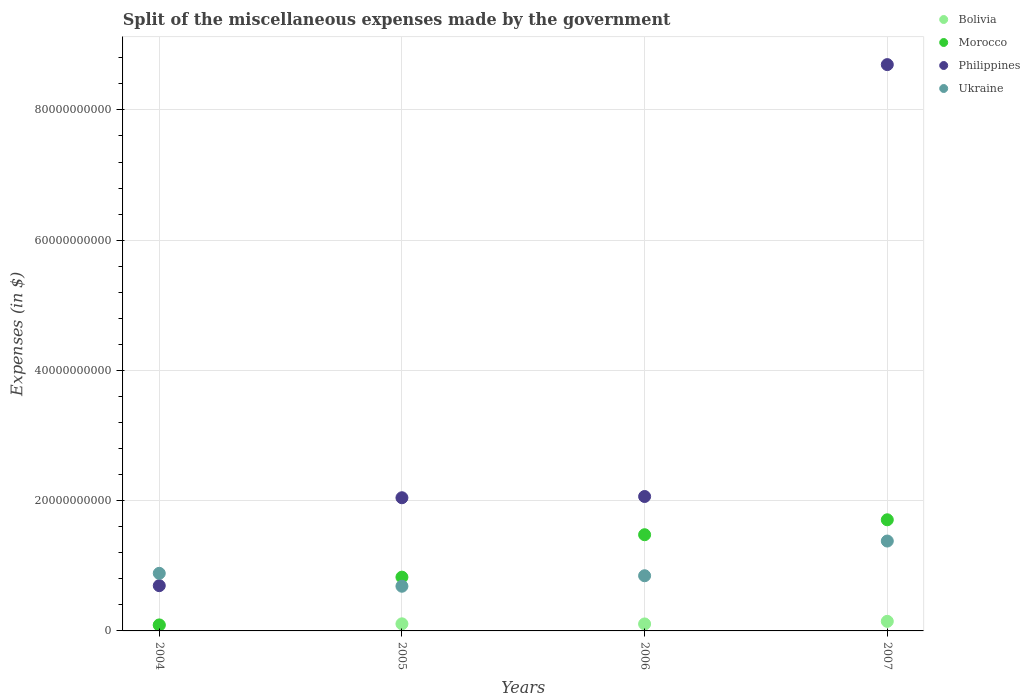How many different coloured dotlines are there?
Provide a short and direct response. 4. What is the miscellaneous expenses made by the government in Morocco in 2006?
Ensure brevity in your answer.  1.48e+1. Across all years, what is the maximum miscellaneous expenses made by the government in Ukraine?
Make the answer very short. 1.38e+1. Across all years, what is the minimum miscellaneous expenses made by the government in Morocco?
Keep it short and to the point. 9.22e+08. What is the total miscellaneous expenses made by the government in Bolivia in the graph?
Provide a succinct answer. 4.49e+09. What is the difference between the miscellaneous expenses made by the government in Ukraine in 2005 and that in 2007?
Ensure brevity in your answer.  -6.94e+09. What is the difference between the miscellaneous expenses made by the government in Philippines in 2005 and the miscellaneous expenses made by the government in Morocco in 2007?
Offer a very short reply. 3.39e+09. What is the average miscellaneous expenses made by the government in Bolivia per year?
Your answer should be compact. 1.12e+09. In the year 2007, what is the difference between the miscellaneous expenses made by the government in Morocco and miscellaneous expenses made by the government in Philippines?
Ensure brevity in your answer.  -6.99e+1. In how many years, is the miscellaneous expenses made by the government in Philippines greater than 32000000000 $?
Make the answer very short. 1. What is the ratio of the miscellaneous expenses made by the government in Philippines in 2006 to that in 2007?
Give a very brief answer. 0.24. Is the miscellaneous expenses made by the government in Ukraine in 2004 less than that in 2006?
Offer a terse response. No. Is the difference between the miscellaneous expenses made by the government in Morocco in 2006 and 2007 greater than the difference between the miscellaneous expenses made by the government in Philippines in 2006 and 2007?
Provide a succinct answer. Yes. What is the difference between the highest and the second highest miscellaneous expenses made by the government in Philippines?
Your answer should be very brief. 6.63e+1. What is the difference between the highest and the lowest miscellaneous expenses made by the government in Ukraine?
Your answer should be compact. 6.94e+09. Is it the case that in every year, the sum of the miscellaneous expenses made by the government in Bolivia and miscellaneous expenses made by the government in Philippines  is greater than the miscellaneous expenses made by the government in Ukraine?
Ensure brevity in your answer.  No. Does the miscellaneous expenses made by the government in Bolivia monotonically increase over the years?
Offer a very short reply. No. Is the miscellaneous expenses made by the government in Ukraine strictly greater than the miscellaneous expenses made by the government in Bolivia over the years?
Your answer should be very brief. Yes. How many years are there in the graph?
Offer a very short reply. 4. What is the difference between two consecutive major ticks on the Y-axis?
Offer a very short reply. 2.00e+1. Are the values on the major ticks of Y-axis written in scientific E-notation?
Offer a very short reply. No. Where does the legend appear in the graph?
Offer a terse response. Top right. How many legend labels are there?
Make the answer very short. 4. What is the title of the graph?
Your answer should be very brief. Split of the miscellaneous expenses made by the government. What is the label or title of the X-axis?
Your answer should be compact. Years. What is the label or title of the Y-axis?
Provide a succinct answer. Expenses (in $). What is the Expenses (in $) in Bolivia in 2004?
Offer a terse response. 8.59e+08. What is the Expenses (in $) in Morocco in 2004?
Provide a short and direct response. 9.22e+08. What is the Expenses (in $) of Philippines in 2004?
Offer a terse response. 6.95e+09. What is the Expenses (in $) of Ukraine in 2004?
Your answer should be compact. 8.84e+09. What is the Expenses (in $) in Bolivia in 2005?
Make the answer very short. 1.09e+09. What is the Expenses (in $) in Morocco in 2005?
Provide a succinct answer. 8.26e+09. What is the Expenses (in $) of Philippines in 2005?
Your answer should be very brief. 2.04e+1. What is the Expenses (in $) of Ukraine in 2005?
Your answer should be compact. 6.86e+09. What is the Expenses (in $) in Bolivia in 2006?
Provide a short and direct response. 1.07e+09. What is the Expenses (in $) in Morocco in 2006?
Offer a very short reply. 1.48e+1. What is the Expenses (in $) of Philippines in 2006?
Keep it short and to the point. 2.06e+1. What is the Expenses (in $) of Ukraine in 2006?
Offer a very short reply. 8.47e+09. What is the Expenses (in $) of Bolivia in 2007?
Provide a short and direct response. 1.47e+09. What is the Expenses (in $) of Morocco in 2007?
Your answer should be compact. 1.71e+1. What is the Expenses (in $) in Philippines in 2007?
Provide a short and direct response. 8.70e+1. What is the Expenses (in $) of Ukraine in 2007?
Your answer should be very brief. 1.38e+1. Across all years, what is the maximum Expenses (in $) of Bolivia?
Offer a terse response. 1.47e+09. Across all years, what is the maximum Expenses (in $) of Morocco?
Give a very brief answer. 1.71e+1. Across all years, what is the maximum Expenses (in $) in Philippines?
Ensure brevity in your answer.  8.70e+1. Across all years, what is the maximum Expenses (in $) in Ukraine?
Your response must be concise. 1.38e+1. Across all years, what is the minimum Expenses (in $) of Bolivia?
Offer a terse response. 8.59e+08. Across all years, what is the minimum Expenses (in $) of Morocco?
Your answer should be very brief. 9.22e+08. Across all years, what is the minimum Expenses (in $) in Philippines?
Offer a terse response. 6.95e+09. Across all years, what is the minimum Expenses (in $) of Ukraine?
Give a very brief answer. 6.86e+09. What is the total Expenses (in $) of Bolivia in the graph?
Give a very brief answer. 4.49e+09. What is the total Expenses (in $) in Morocco in the graph?
Give a very brief answer. 4.10e+1. What is the total Expenses (in $) in Philippines in the graph?
Offer a terse response. 1.35e+11. What is the total Expenses (in $) in Ukraine in the graph?
Provide a short and direct response. 3.80e+1. What is the difference between the Expenses (in $) in Bolivia in 2004 and that in 2005?
Your answer should be very brief. -2.29e+08. What is the difference between the Expenses (in $) of Morocco in 2004 and that in 2005?
Make the answer very short. -7.33e+09. What is the difference between the Expenses (in $) of Philippines in 2004 and that in 2005?
Keep it short and to the point. -1.35e+1. What is the difference between the Expenses (in $) of Ukraine in 2004 and that in 2005?
Keep it short and to the point. 1.98e+09. What is the difference between the Expenses (in $) in Bolivia in 2004 and that in 2006?
Provide a short and direct response. -2.11e+08. What is the difference between the Expenses (in $) of Morocco in 2004 and that in 2006?
Offer a very short reply. -1.38e+1. What is the difference between the Expenses (in $) of Philippines in 2004 and that in 2006?
Your answer should be very brief. -1.37e+1. What is the difference between the Expenses (in $) of Ukraine in 2004 and that in 2006?
Provide a succinct answer. 3.71e+08. What is the difference between the Expenses (in $) of Bolivia in 2004 and that in 2007?
Your answer should be very brief. -6.12e+08. What is the difference between the Expenses (in $) in Morocco in 2004 and that in 2007?
Offer a terse response. -1.61e+1. What is the difference between the Expenses (in $) of Philippines in 2004 and that in 2007?
Offer a very short reply. -8.00e+1. What is the difference between the Expenses (in $) of Ukraine in 2004 and that in 2007?
Offer a terse response. -4.96e+09. What is the difference between the Expenses (in $) of Bolivia in 2005 and that in 2006?
Your response must be concise. 1.75e+07. What is the difference between the Expenses (in $) of Morocco in 2005 and that in 2006?
Your answer should be very brief. -6.52e+09. What is the difference between the Expenses (in $) of Philippines in 2005 and that in 2006?
Your answer should be very brief. -1.90e+08. What is the difference between the Expenses (in $) in Ukraine in 2005 and that in 2006?
Keep it short and to the point. -1.61e+09. What is the difference between the Expenses (in $) of Bolivia in 2005 and that in 2007?
Ensure brevity in your answer.  -3.83e+08. What is the difference between the Expenses (in $) of Morocco in 2005 and that in 2007?
Offer a very short reply. -8.81e+09. What is the difference between the Expenses (in $) of Philippines in 2005 and that in 2007?
Provide a succinct answer. -6.65e+1. What is the difference between the Expenses (in $) of Ukraine in 2005 and that in 2007?
Your answer should be very brief. -6.94e+09. What is the difference between the Expenses (in $) in Bolivia in 2006 and that in 2007?
Make the answer very short. -4.00e+08. What is the difference between the Expenses (in $) in Morocco in 2006 and that in 2007?
Your answer should be compact. -2.29e+09. What is the difference between the Expenses (in $) in Philippines in 2006 and that in 2007?
Provide a short and direct response. -6.63e+1. What is the difference between the Expenses (in $) of Ukraine in 2006 and that in 2007?
Offer a terse response. -5.33e+09. What is the difference between the Expenses (in $) of Bolivia in 2004 and the Expenses (in $) of Morocco in 2005?
Ensure brevity in your answer.  -7.40e+09. What is the difference between the Expenses (in $) of Bolivia in 2004 and the Expenses (in $) of Philippines in 2005?
Keep it short and to the point. -1.96e+1. What is the difference between the Expenses (in $) of Bolivia in 2004 and the Expenses (in $) of Ukraine in 2005?
Give a very brief answer. -6.00e+09. What is the difference between the Expenses (in $) in Morocco in 2004 and the Expenses (in $) in Philippines in 2005?
Your response must be concise. -1.95e+1. What is the difference between the Expenses (in $) of Morocco in 2004 and the Expenses (in $) of Ukraine in 2005?
Give a very brief answer. -5.94e+09. What is the difference between the Expenses (in $) of Philippines in 2004 and the Expenses (in $) of Ukraine in 2005?
Keep it short and to the point. 8.90e+07. What is the difference between the Expenses (in $) in Bolivia in 2004 and the Expenses (in $) in Morocco in 2006?
Offer a terse response. -1.39e+1. What is the difference between the Expenses (in $) of Bolivia in 2004 and the Expenses (in $) of Philippines in 2006?
Give a very brief answer. -1.98e+1. What is the difference between the Expenses (in $) in Bolivia in 2004 and the Expenses (in $) in Ukraine in 2006?
Give a very brief answer. -7.61e+09. What is the difference between the Expenses (in $) in Morocco in 2004 and the Expenses (in $) in Philippines in 2006?
Your answer should be compact. -1.97e+1. What is the difference between the Expenses (in $) of Morocco in 2004 and the Expenses (in $) of Ukraine in 2006?
Offer a very short reply. -7.55e+09. What is the difference between the Expenses (in $) in Philippines in 2004 and the Expenses (in $) in Ukraine in 2006?
Make the answer very short. -1.52e+09. What is the difference between the Expenses (in $) in Bolivia in 2004 and the Expenses (in $) in Morocco in 2007?
Give a very brief answer. -1.62e+1. What is the difference between the Expenses (in $) of Bolivia in 2004 and the Expenses (in $) of Philippines in 2007?
Provide a short and direct response. -8.61e+1. What is the difference between the Expenses (in $) of Bolivia in 2004 and the Expenses (in $) of Ukraine in 2007?
Provide a short and direct response. -1.29e+1. What is the difference between the Expenses (in $) in Morocco in 2004 and the Expenses (in $) in Philippines in 2007?
Provide a succinct answer. -8.60e+1. What is the difference between the Expenses (in $) in Morocco in 2004 and the Expenses (in $) in Ukraine in 2007?
Your response must be concise. -1.29e+1. What is the difference between the Expenses (in $) of Philippines in 2004 and the Expenses (in $) of Ukraine in 2007?
Keep it short and to the point. -6.85e+09. What is the difference between the Expenses (in $) of Bolivia in 2005 and the Expenses (in $) of Morocco in 2006?
Your answer should be compact. -1.37e+1. What is the difference between the Expenses (in $) in Bolivia in 2005 and the Expenses (in $) in Philippines in 2006?
Provide a succinct answer. -1.96e+1. What is the difference between the Expenses (in $) in Bolivia in 2005 and the Expenses (in $) in Ukraine in 2006?
Provide a short and direct response. -7.38e+09. What is the difference between the Expenses (in $) of Morocco in 2005 and the Expenses (in $) of Philippines in 2006?
Your response must be concise. -1.24e+1. What is the difference between the Expenses (in $) in Morocco in 2005 and the Expenses (in $) in Ukraine in 2006?
Ensure brevity in your answer.  -2.17e+08. What is the difference between the Expenses (in $) of Philippines in 2005 and the Expenses (in $) of Ukraine in 2006?
Your answer should be very brief. 1.20e+1. What is the difference between the Expenses (in $) of Bolivia in 2005 and the Expenses (in $) of Morocco in 2007?
Your answer should be compact. -1.60e+1. What is the difference between the Expenses (in $) in Bolivia in 2005 and the Expenses (in $) in Philippines in 2007?
Your response must be concise. -8.59e+1. What is the difference between the Expenses (in $) in Bolivia in 2005 and the Expenses (in $) in Ukraine in 2007?
Your answer should be very brief. -1.27e+1. What is the difference between the Expenses (in $) in Morocco in 2005 and the Expenses (in $) in Philippines in 2007?
Your response must be concise. -7.87e+1. What is the difference between the Expenses (in $) in Morocco in 2005 and the Expenses (in $) in Ukraine in 2007?
Give a very brief answer. -5.55e+09. What is the difference between the Expenses (in $) of Philippines in 2005 and the Expenses (in $) of Ukraine in 2007?
Make the answer very short. 6.65e+09. What is the difference between the Expenses (in $) in Bolivia in 2006 and the Expenses (in $) in Morocco in 2007?
Provide a short and direct response. -1.60e+1. What is the difference between the Expenses (in $) of Bolivia in 2006 and the Expenses (in $) of Philippines in 2007?
Provide a succinct answer. -8.59e+1. What is the difference between the Expenses (in $) in Bolivia in 2006 and the Expenses (in $) in Ukraine in 2007?
Provide a succinct answer. -1.27e+1. What is the difference between the Expenses (in $) in Morocco in 2006 and the Expenses (in $) in Philippines in 2007?
Offer a terse response. -7.22e+1. What is the difference between the Expenses (in $) in Morocco in 2006 and the Expenses (in $) in Ukraine in 2007?
Make the answer very short. 9.70e+08. What is the difference between the Expenses (in $) of Philippines in 2006 and the Expenses (in $) of Ukraine in 2007?
Provide a short and direct response. 6.84e+09. What is the average Expenses (in $) in Bolivia per year?
Give a very brief answer. 1.12e+09. What is the average Expenses (in $) of Morocco per year?
Offer a terse response. 1.03e+1. What is the average Expenses (in $) in Philippines per year?
Give a very brief answer. 3.37e+1. What is the average Expenses (in $) of Ukraine per year?
Offer a very short reply. 9.49e+09. In the year 2004, what is the difference between the Expenses (in $) in Bolivia and Expenses (in $) in Morocco?
Your response must be concise. -6.23e+07. In the year 2004, what is the difference between the Expenses (in $) of Bolivia and Expenses (in $) of Philippines?
Provide a short and direct response. -6.09e+09. In the year 2004, what is the difference between the Expenses (in $) in Bolivia and Expenses (in $) in Ukraine?
Ensure brevity in your answer.  -7.98e+09. In the year 2004, what is the difference between the Expenses (in $) of Morocco and Expenses (in $) of Philippines?
Offer a terse response. -6.03e+09. In the year 2004, what is the difference between the Expenses (in $) of Morocco and Expenses (in $) of Ukraine?
Your response must be concise. -7.92e+09. In the year 2004, what is the difference between the Expenses (in $) in Philippines and Expenses (in $) in Ukraine?
Provide a short and direct response. -1.89e+09. In the year 2005, what is the difference between the Expenses (in $) in Bolivia and Expenses (in $) in Morocco?
Provide a succinct answer. -7.17e+09. In the year 2005, what is the difference between the Expenses (in $) of Bolivia and Expenses (in $) of Philippines?
Your answer should be compact. -1.94e+1. In the year 2005, what is the difference between the Expenses (in $) of Bolivia and Expenses (in $) of Ukraine?
Offer a terse response. -5.77e+09. In the year 2005, what is the difference between the Expenses (in $) in Morocco and Expenses (in $) in Philippines?
Keep it short and to the point. -1.22e+1. In the year 2005, what is the difference between the Expenses (in $) in Morocco and Expenses (in $) in Ukraine?
Your response must be concise. 1.39e+09. In the year 2005, what is the difference between the Expenses (in $) of Philippines and Expenses (in $) of Ukraine?
Give a very brief answer. 1.36e+1. In the year 2006, what is the difference between the Expenses (in $) of Bolivia and Expenses (in $) of Morocco?
Offer a terse response. -1.37e+1. In the year 2006, what is the difference between the Expenses (in $) in Bolivia and Expenses (in $) in Philippines?
Offer a very short reply. -1.96e+1. In the year 2006, what is the difference between the Expenses (in $) of Bolivia and Expenses (in $) of Ukraine?
Your response must be concise. -7.40e+09. In the year 2006, what is the difference between the Expenses (in $) in Morocco and Expenses (in $) in Philippines?
Your answer should be compact. -5.87e+09. In the year 2006, what is the difference between the Expenses (in $) in Morocco and Expenses (in $) in Ukraine?
Offer a very short reply. 6.30e+09. In the year 2006, what is the difference between the Expenses (in $) of Philippines and Expenses (in $) of Ukraine?
Provide a succinct answer. 1.22e+1. In the year 2007, what is the difference between the Expenses (in $) of Bolivia and Expenses (in $) of Morocco?
Ensure brevity in your answer.  -1.56e+1. In the year 2007, what is the difference between the Expenses (in $) in Bolivia and Expenses (in $) in Philippines?
Make the answer very short. -8.55e+1. In the year 2007, what is the difference between the Expenses (in $) of Bolivia and Expenses (in $) of Ukraine?
Provide a succinct answer. -1.23e+1. In the year 2007, what is the difference between the Expenses (in $) in Morocco and Expenses (in $) in Philippines?
Provide a short and direct response. -6.99e+1. In the year 2007, what is the difference between the Expenses (in $) in Morocco and Expenses (in $) in Ukraine?
Make the answer very short. 3.26e+09. In the year 2007, what is the difference between the Expenses (in $) of Philippines and Expenses (in $) of Ukraine?
Make the answer very short. 7.32e+1. What is the ratio of the Expenses (in $) in Bolivia in 2004 to that in 2005?
Keep it short and to the point. 0.79. What is the ratio of the Expenses (in $) in Morocco in 2004 to that in 2005?
Your response must be concise. 0.11. What is the ratio of the Expenses (in $) in Philippines in 2004 to that in 2005?
Offer a terse response. 0.34. What is the ratio of the Expenses (in $) in Ukraine in 2004 to that in 2005?
Keep it short and to the point. 1.29. What is the ratio of the Expenses (in $) of Bolivia in 2004 to that in 2006?
Keep it short and to the point. 0.8. What is the ratio of the Expenses (in $) in Morocco in 2004 to that in 2006?
Your answer should be compact. 0.06. What is the ratio of the Expenses (in $) of Philippines in 2004 to that in 2006?
Offer a terse response. 0.34. What is the ratio of the Expenses (in $) in Ukraine in 2004 to that in 2006?
Offer a very short reply. 1.04. What is the ratio of the Expenses (in $) in Bolivia in 2004 to that in 2007?
Provide a short and direct response. 0.58. What is the ratio of the Expenses (in $) in Morocco in 2004 to that in 2007?
Offer a very short reply. 0.05. What is the ratio of the Expenses (in $) in Philippines in 2004 to that in 2007?
Give a very brief answer. 0.08. What is the ratio of the Expenses (in $) in Ukraine in 2004 to that in 2007?
Your response must be concise. 0.64. What is the ratio of the Expenses (in $) of Bolivia in 2005 to that in 2006?
Provide a succinct answer. 1.02. What is the ratio of the Expenses (in $) in Morocco in 2005 to that in 2006?
Your answer should be compact. 0.56. What is the ratio of the Expenses (in $) in Ukraine in 2005 to that in 2006?
Your response must be concise. 0.81. What is the ratio of the Expenses (in $) of Bolivia in 2005 to that in 2007?
Your answer should be compact. 0.74. What is the ratio of the Expenses (in $) of Morocco in 2005 to that in 2007?
Provide a succinct answer. 0.48. What is the ratio of the Expenses (in $) of Philippines in 2005 to that in 2007?
Keep it short and to the point. 0.24. What is the ratio of the Expenses (in $) in Ukraine in 2005 to that in 2007?
Make the answer very short. 0.5. What is the ratio of the Expenses (in $) in Bolivia in 2006 to that in 2007?
Your answer should be compact. 0.73. What is the ratio of the Expenses (in $) of Morocco in 2006 to that in 2007?
Offer a terse response. 0.87. What is the ratio of the Expenses (in $) in Philippines in 2006 to that in 2007?
Offer a terse response. 0.24. What is the ratio of the Expenses (in $) of Ukraine in 2006 to that in 2007?
Make the answer very short. 0.61. What is the difference between the highest and the second highest Expenses (in $) in Bolivia?
Provide a short and direct response. 3.83e+08. What is the difference between the highest and the second highest Expenses (in $) in Morocco?
Keep it short and to the point. 2.29e+09. What is the difference between the highest and the second highest Expenses (in $) of Philippines?
Provide a short and direct response. 6.63e+1. What is the difference between the highest and the second highest Expenses (in $) in Ukraine?
Provide a short and direct response. 4.96e+09. What is the difference between the highest and the lowest Expenses (in $) in Bolivia?
Provide a succinct answer. 6.12e+08. What is the difference between the highest and the lowest Expenses (in $) in Morocco?
Keep it short and to the point. 1.61e+1. What is the difference between the highest and the lowest Expenses (in $) in Philippines?
Provide a succinct answer. 8.00e+1. What is the difference between the highest and the lowest Expenses (in $) in Ukraine?
Provide a succinct answer. 6.94e+09. 